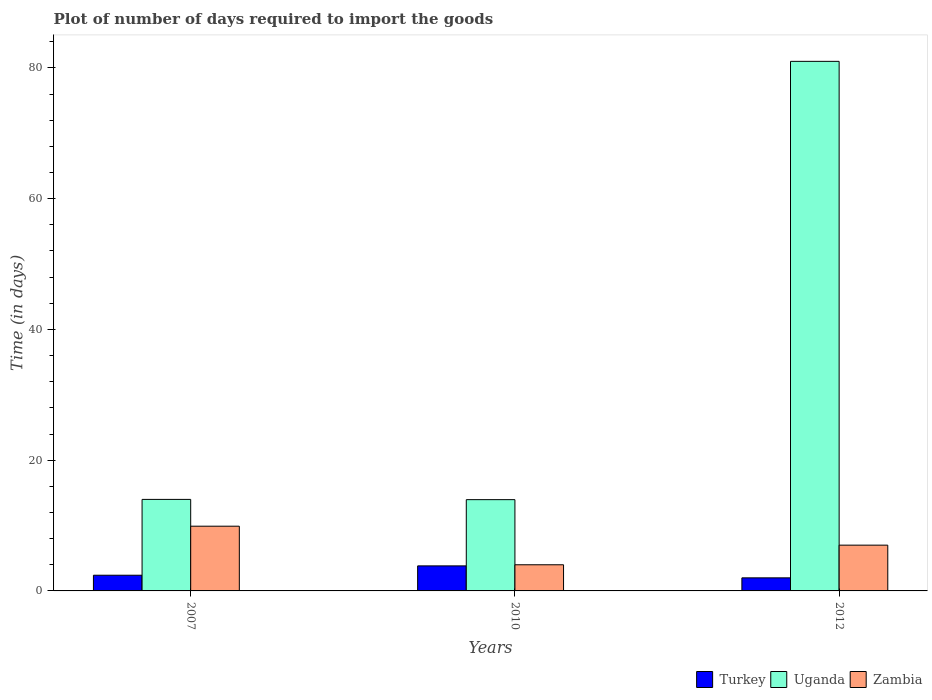Are the number of bars per tick equal to the number of legend labels?
Offer a very short reply. Yes. What is the label of the 2nd group of bars from the left?
Provide a short and direct response. 2010. In how many cases, is the number of bars for a given year not equal to the number of legend labels?
Ensure brevity in your answer.  0. Across all years, what is the maximum time required to import goods in Zambia?
Make the answer very short. 9.9. Across all years, what is the minimum time required to import goods in Uganda?
Your answer should be very brief. 13.96. In which year was the time required to import goods in Uganda maximum?
Provide a short and direct response. 2012. In which year was the time required to import goods in Turkey minimum?
Offer a very short reply. 2012. What is the total time required to import goods in Uganda in the graph?
Make the answer very short. 108.96. What is the difference between the time required to import goods in Uganda in 2007 and that in 2010?
Keep it short and to the point. 0.04. What is the difference between the time required to import goods in Uganda in 2007 and the time required to import goods in Zambia in 2012?
Ensure brevity in your answer.  7. What is the average time required to import goods in Turkey per year?
Ensure brevity in your answer.  2.74. What is the ratio of the time required to import goods in Turkey in 2007 to that in 2010?
Your response must be concise. 0.63. Is the difference between the time required to import goods in Turkey in 2007 and 2012 greater than the difference between the time required to import goods in Uganda in 2007 and 2012?
Offer a very short reply. Yes. What does the 1st bar from the left in 2012 represents?
Make the answer very short. Turkey. What does the 3rd bar from the right in 2012 represents?
Make the answer very short. Turkey. Are all the bars in the graph horizontal?
Your response must be concise. No. How many years are there in the graph?
Ensure brevity in your answer.  3. How are the legend labels stacked?
Keep it short and to the point. Horizontal. What is the title of the graph?
Provide a short and direct response. Plot of number of days required to import the goods. Does "Spain" appear as one of the legend labels in the graph?
Offer a very short reply. No. What is the label or title of the X-axis?
Offer a terse response. Years. What is the label or title of the Y-axis?
Provide a succinct answer. Time (in days). What is the Time (in days) of Turkey in 2010?
Your answer should be very brief. 3.83. What is the Time (in days) of Uganda in 2010?
Keep it short and to the point. 13.96. What is the Time (in days) in Uganda in 2012?
Keep it short and to the point. 81. Across all years, what is the maximum Time (in days) in Turkey?
Your answer should be very brief. 3.83. Across all years, what is the minimum Time (in days) of Uganda?
Your answer should be compact. 13.96. What is the total Time (in days) of Turkey in the graph?
Keep it short and to the point. 8.23. What is the total Time (in days) in Uganda in the graph?
Offer a terse response. 108.96. What is the total Time (in days) in Zambia in the graph?
Provide a short and direct response. 20.9. What is the difference between the Time (in days) in Turkey in 2007 and that in 2010?
Ensure brevity in your answer.  -1.43. What is the difference between the Time (in days) in Uganda in 2007 and that in 2012?
Provide a short and direct response. -67. What is the difference between the Time (in days) in Turkey in 2010 and that in 2012?
Your answer should be compact. 1.83. What is the difference between the Time (in days) of Uganda in 2010 and that in 2012?
Give a very brief answer. -67.04. What is the difference between the Time (in days) in Turkey in 2007 and the Time (in days) in Uganda in 2010?
Provide a succinct answer. -11.56. What is the difference between the Time (in days) of Turkey in 2007 and the Time (in days) of Zambia in 2010?
Ensure brevity in your answer.  -1.6. What is the difference between the Time (in days) in Uganda in 2007 and the Time (in days) in Zambia in 2010?
Your answer should be very brief. 10. What is the difference between the Time (in days) in Turkey in 2007 and the Time (in days) in Uganda in 2012?
Your response must be concise. -78.6. What is the difference between the Time (in days) of Turkey in 2007 and the Time (in days) of Zambia in 2012?
Make the answer very short. -4.6. What is the difference between the Time (in days) of Uganda in 2007 and the Time (in days) of Zambia in 2012?
Your response must be concise. 7. What is the difference between the Time (in days) of Turkey in 2010 and the Time (in days) of Uganda in 2012?
Your answer should be compact. -77.17. What is the difference between the Time (in days) of Turkey in 2010 and the Time (in days) of Zambia in 2012?
Your answer should be very brief. -3.17. What is the difference between the Time (in days) in Uganda in 2010 and the Time (in days) in Zambia in 2012?
Keep it short and to the point. 6.96. What is the average Time (in days) of Turkey per year?
Offer a very short reply. 2.74. What is the average Time (in days) in Uganda per year?
Ensure brevity in your answer.  36.32. What is the average Time (in days) in Zambia per year?
Provide a short and direct response. 6.97. In the year 2007, what is the difference between the Time (in days) in Uganda and Time (in days) in Zambia?
Keep it short and to the point. 4.1. In the year 2010, what is the difference between the Time (in days) in Turkey and Time (in days) in Uganda?
Provide a succinct answer. -10.13. In the year 2010, what is the difference between the Time (in days) of Turkey and Time (in days) of Zambia?
Give a very brief answer. -0.17. In the year 2010, what is the difference between the Time (in days) of Uganda and Time (in days) of Zambia?
Your response must be concise. 9.96. In the year 2012, what is the difference between the Time (in days) in Turkey and Time (in days) in Uganda?
Keep it short and to the point. -79. What is the ratio of the Time (in days) of Turkey in 2007 to that in 2010?
Your answer should be compact. 0.63. What is the ratio of the Time (in days) in Zambia in 2007 to that in 2010?
Provide a short and direct response. 2.48. What is the ratio of the Time (in days) of Turkey in 2007 to that in 2012?
Your answer should be compact. 1.2. What is the ratio of the Time (in days) in Uganda in 2007 to that in 2012?
Your answer should be compact. 0.17. What is the ratio of the Time (in days) of Zambia in 2007 to that in 2012?
Make the answer very short. 1.41. What is the ratio of the Time (in days) in Turkey in 2010 to that in 2012?
Give a very brief answer. 1.92. What is the ratio of the Time (in days) in Uganda in 2010 to that in 2012?
Offer a terse response. 0.17. What is the ratio of the Time (in days) in Zambia in 2010 to that in 2012?
Provide a short and direct response. 0.57. What is the difference between the highest and the second highest Time (in days) in Turkey?
Provide a succinct answer. 1.43. What is the difference between the highest and the lowest Time (in days) in Turkey?
Ensure brevity in your answer.  1.83. What is the difference between the highest and the lowest Time (in days) in Uganda?
Provide a short and direct response. 67.04. 